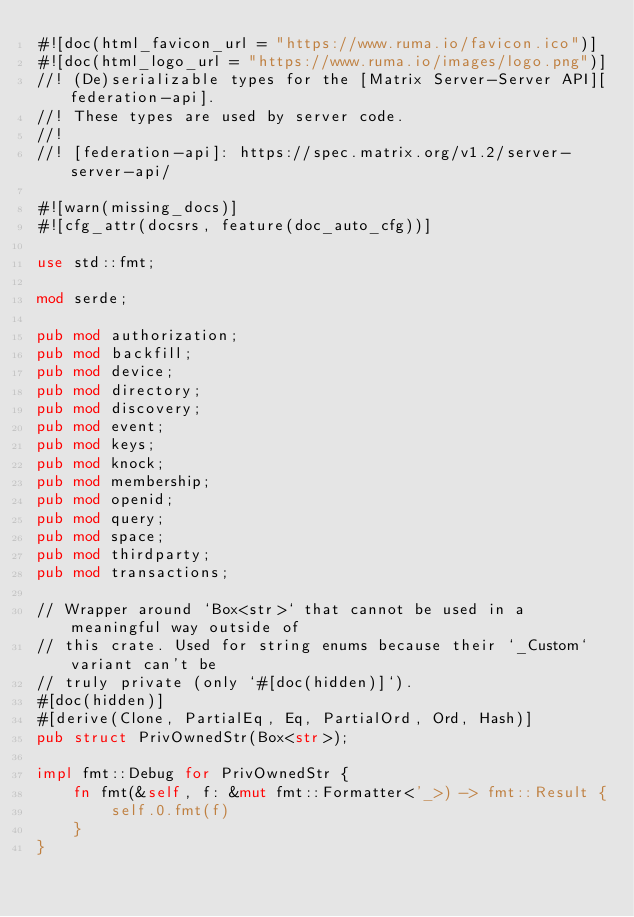Convert code to text. <code><loc_0><loc_0><loc_500><loc_500><_Rust_>#![doc(html_favicon_url = "https://www.ruma.io/favicon.ico")]
#![doc(html_logo_url = "https://www.ruma.io/images/logo.png")]
//! (De)serializable types for the [Matrix Server-Server API][federation-api].
//! These types are used by server code.
//!
//! [federation-api]: https://spec.matrix.org/v1.2/server-server-api/

#![warn(missing_docs)]
#![cfg_attr(docsrs, feature(doc_auto_cfg))]

use std::fmt;

mod serde;

pub mod authorization;
pub mod backfill;
pub mod device;
pub mod directory;
pub mod discovery;
pub mod event;
pub mod keys;
pub mod knock;
pub mod membership;
pub mod openid;
pub mod query;
pub mod space;
pub mod thirdparty;
pub mod transactions;

// Wrapper around `Box<str>` that cannot be used in a meaningful way outside of
// this crate. Used for string enums because their `_Custom` variant can't be
// truly private (only `#[doc(hidden)]`).
#[doc(hidden)]
#[derive(Clone, PartialEq, Eq, PartialOrd, Ord, Hash)]
pub struct PrivOwnedStr(Box<str>);

impl fmt::Debug for PrivOwnedStr {
    fn fmt(&self, f: &mut fmt::Formatter<'_>) -> fmt::Result {
        self.0.fmt(f)
    }
}
</code> 